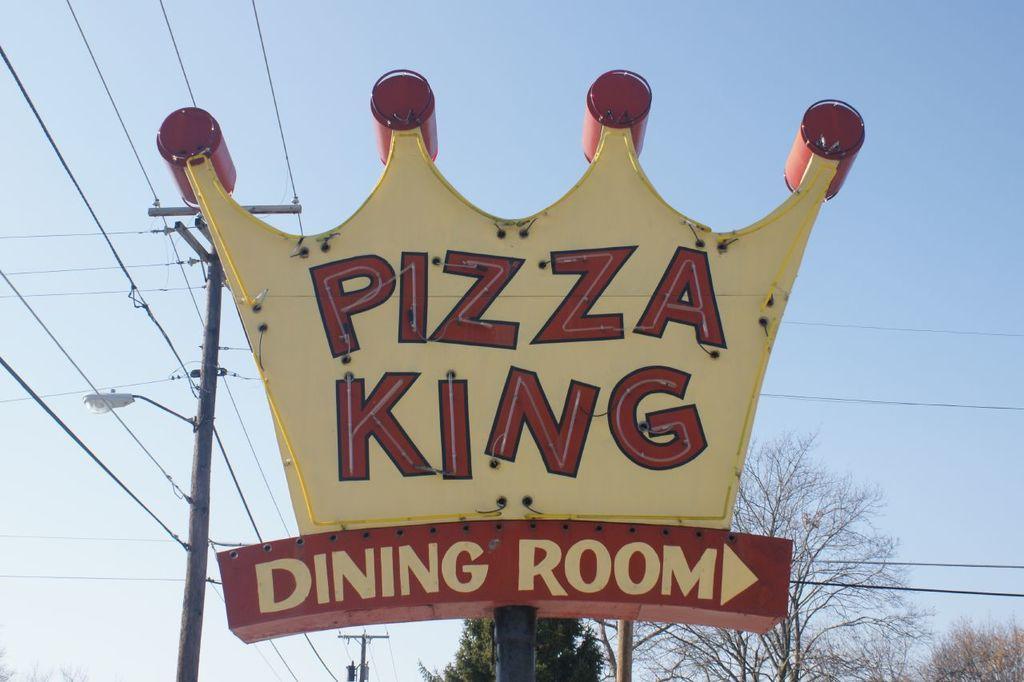Can you describe this image briefly? In this picture we can see a name board. Behind the name board there are trees and there are electric poles with cables. Behind the trees there is the sky. 